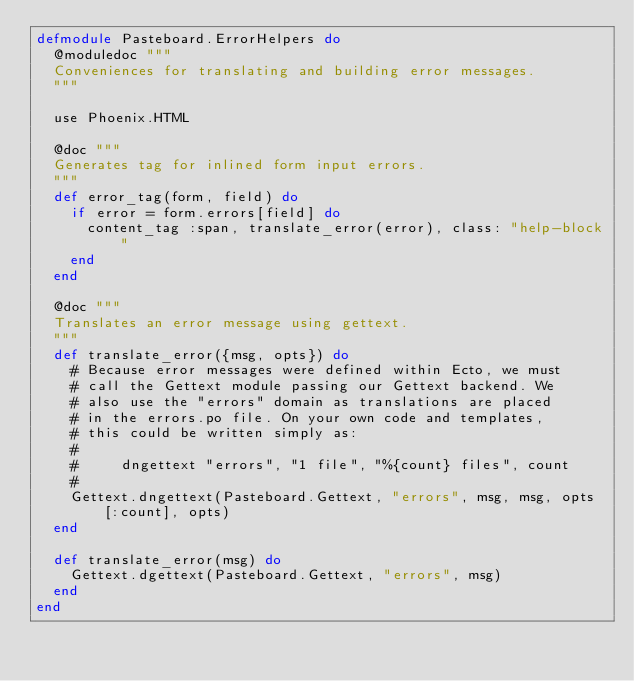<code> <loc_0><loc_0><loc_500><loc_500><_Elixir_>defmodule Pasteboard.ErrorHelpers do
  @moduledoc """
  Conveniences for translating and building error messages.
  """

  use Phoenix.HTML

  @doc """
  Generates tag for inlined form input errors.
  """
  def error_tag(form, field) do
    if error = form.errors[field] do
      content_tag :span, translate_error(error), class: "help-block"
    end
  end

  @doc """
  Translates an error message using gettext.
  """
  def translate_error({msg, opts}) do
    # Because error messages were defined within Ecto, we must
    # call the Gettext module passing our Gettext backend. We
    # also use the "errors" domain as translations are placed
    # in the errors.po file. On your own code and templates,
    # this could be written simply as:
    #
    #     dngettext "errors", "1 file", "%{count} files", count
    #
    Gettext.dngettext(Pasteboard.Gettext, "errors", msg, msg, opts[:count], opts)
  end

  def translate_error(msg) do
    Gettext.dgettext(Pasteboard.Gettext, "errors", msg)
  end
end
</code> 